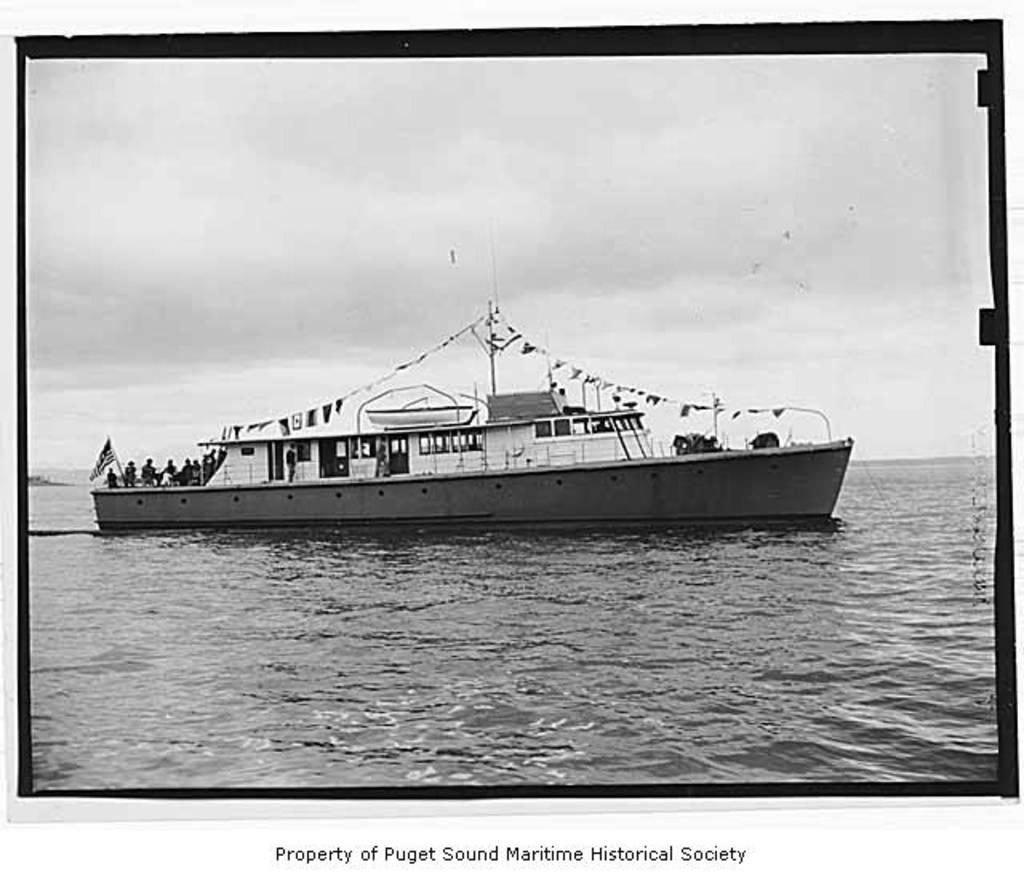Who owns the picture?
Your answer should be very brief. Puget sound maritime historical society. 